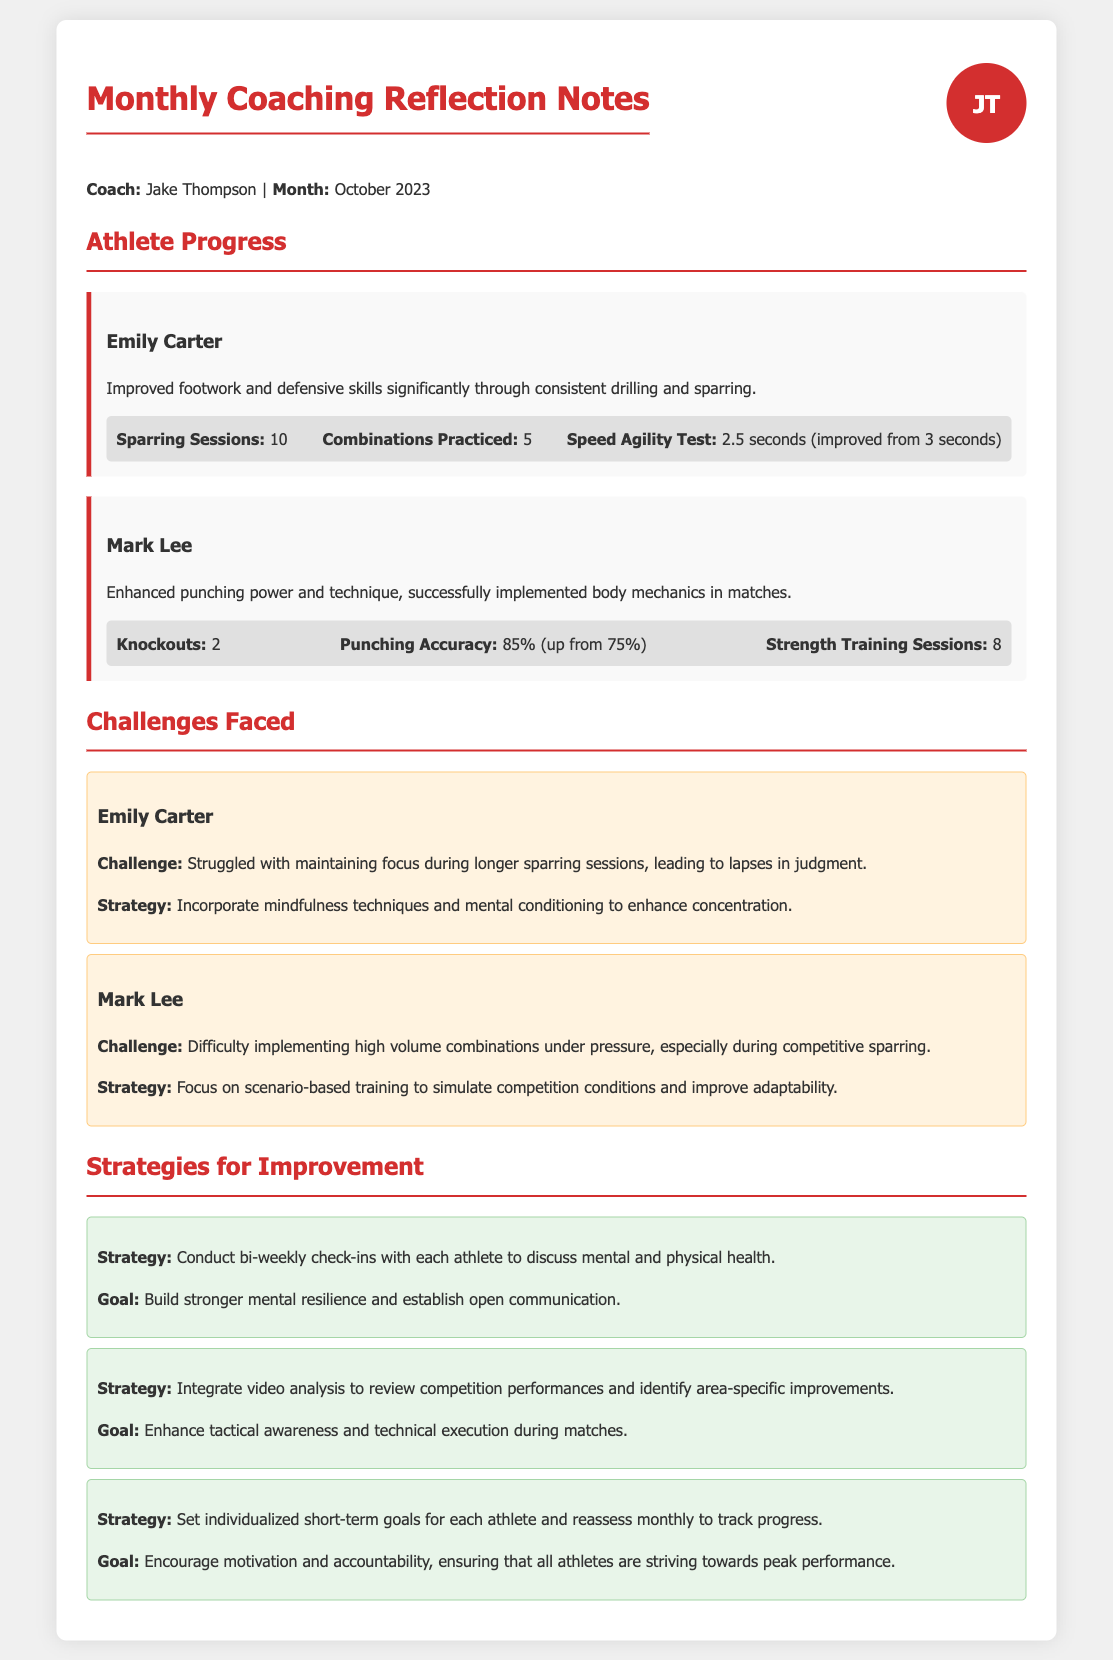What is the coach's name? The coach's name is mentioned at the top of the document as Jake Thompson.
Answer: Jake Thompson How many sparring sessions did Emily Carter complete? The number of sparring sessions for Emily Carter is listed as 10 in her progress section.
Answer: 10 What challenge did Mark Lee face? Mark Lee's challenge is stated as difficulty implementing high volume combinations under pressure during competitive sparring.
Answer: Difficulty implementing high volume combinations What was Emily Carter's improvement in speed agility test time? The improvement in Emily Carter's speed agility test time is calculated from 3 seconds to 2.5 seconds.
Answer: 2.5 seconds What is one strategy for improving mental resilience? One strategy for improving mental resilience is conducting bi-weekly check-ins with athletes to discuss health.
Answer: Conduct bi-weekly check-ins How many knockouts did Mark Lee achieve? Mark Lee achieved 2 knockouts, as mentioned in his metrics.
Answer: 2 What is the goal of integrating video analysis? The goal of integrating video analysis is to enhance tactical awareness and technical execution during matches.
Answer: Enhance tactical awareness How many strength training sessions did Mark Lee have? The number of strength training sessions completed by Mark Lee is stated as 8 in his progress section.
Answer: 8 What specific technique should Emily Carter incorporate to improve focus? The technique mentioned for improving focus for Emily Carter is mindfulness techniques.
Answer: Mindfulness techniques 